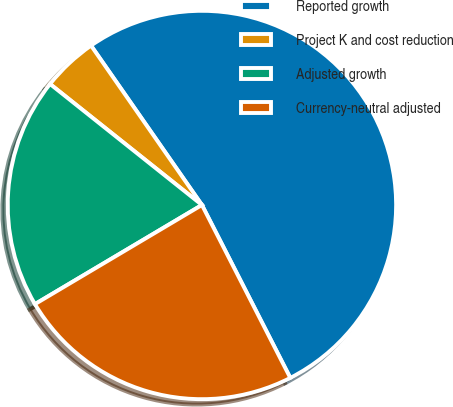Convert chart. <chart><loc_0><loc_0><loc_500><loc_500><pie_chart><fcel>Reported growth<fcel>Project K and cost reduction<fcel>Adjusted growth<fcel>Currency-neutral adjusted<nl><fcel>52.15%<fcel>4.62%<fcel>19.23%<fcel>23.99%<nl></chart> 